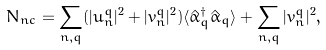Convert formula to latex. <formula><loc_0><loc_0><loc_500><loc_500>N _ { n c } = \sum _ { n , q } ( | u _ { n } ^ { q } | ^ { 2 } + | v _ { n } ^ { q } | ^ { 2 } ) \langle \hat { \alpha } _ { q } ^ { \dagger } \hat { \alpha } _ { q } \rangle + \sum _ { n , q } | v _ { n } ^ { q } | ^ { 2 } ,</formula> 